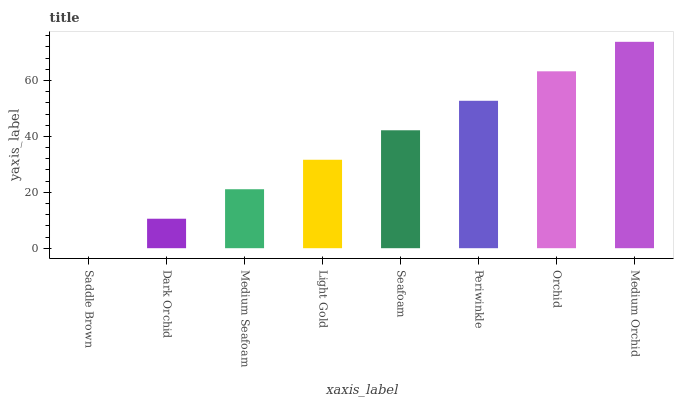Is Dark Orchid the minimum?
Answer yes or no. No. Is Dark Orchid the maximum?
Answer yes or no. No. Is Dark Orchid greater than Saddle Brown?
Answer yes or no. Yes. Is Saddle Brown less than Dark Orchid?
Answer yes or no. Yes. Is Saddle Brown greater than Dark Orchid?
Answer yes or no. No. Is Dark Orchid less than Saddle Brown?
Answer yes or no. No. Is Seafoam the high median?
Answer yes or no. Yes. Is Light Gold the low median?
Answer yes or no. Yes. Is Orchid the high median?
Answer yes or no. No. Is Medium Orchid the low median?
Answer yes or no. No. 